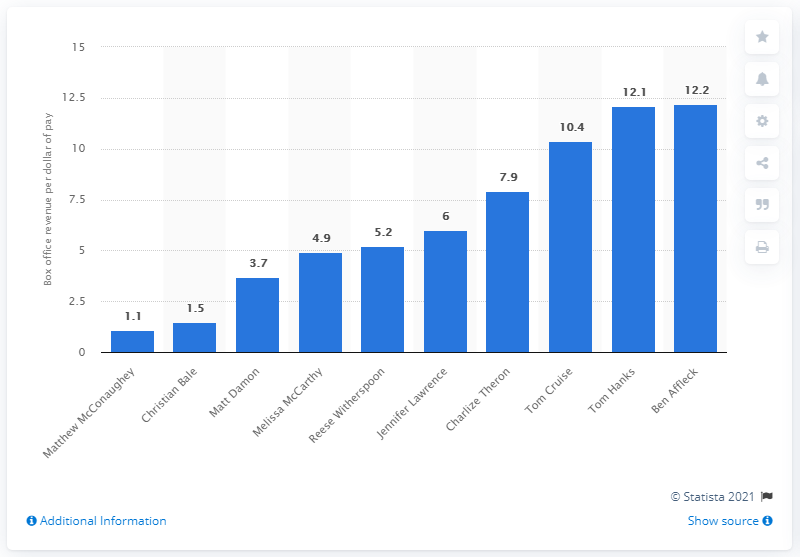Specify some key components in this picture. Christian Bale ranked second on the list with 1.5 dollars per dollar of his pay. 